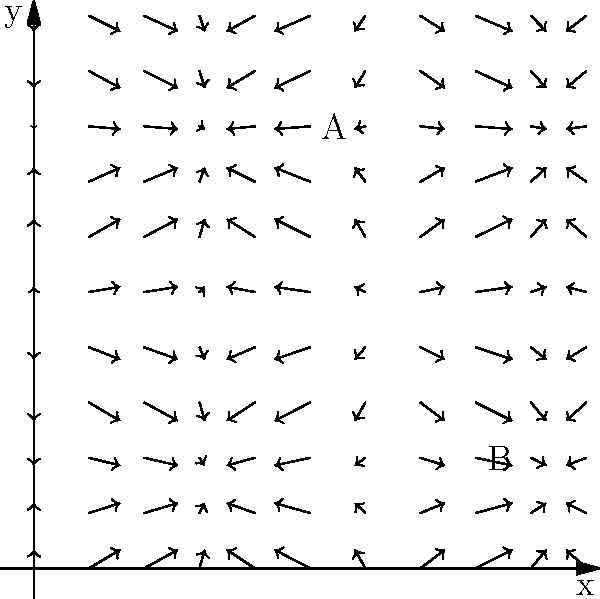Given the vector field representing wind patterns in a sailing area, which path would likely be more favorable for a sailboat traveling from point A to point B?
a) A direct straight line
b) A curved path following the general direction of the wind vectors
c) A zigzag path against the wind vectors To answer this question, we need to analyze the vector field and understand how it relates to sailing:

1. The vector field represents wind patterns, where each arrow shows the direction and relative strength of the wind at that point.

2. Sailboats generally perform best when sailing with the wind or at an angle to it, rather than directly against it.

3. Observing the vector field:
   - Near point A (5,8), the wind is blowing roughly southeast.
   - Near point B (8,2), the wind is blowing roughly east.
   - Between A and B, the wind generally curves from southeast to east.

4. A direct straight line from A to B would require sailing against the wind for part of the journey, which is inefficient.

5. A zigzag path against the wind vectors would be the least efficient, as it would involve constantly sailing against the wind.

6. A curved path following the general direction of the wind vectors would allow the sailboat to utilize the wind's power most effectively, making it the most favorable option.

Therefore, the most favorable path for a sailboat would be a curved route that follows the general direction of the wind vectors, allowing the boat to harness the wind's power throughout most of the journey.
Answer: b) A curved path following the general direction of the wind vectors 